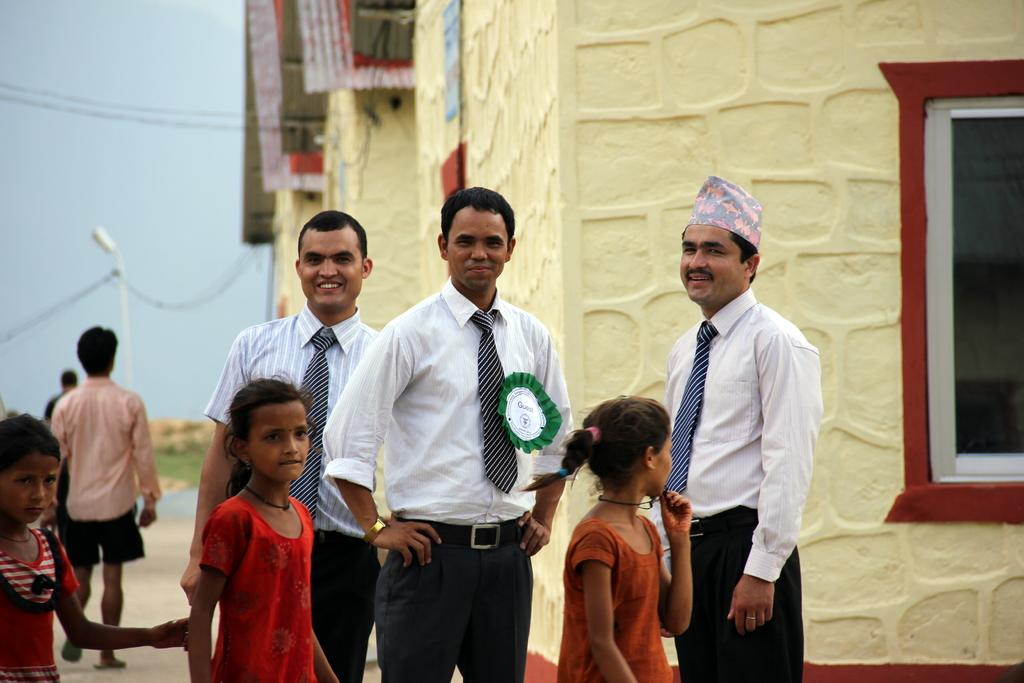What type of structures can be seen in the image? There are houses in the image. What part of a house can be seen in the image? There is a window visible in the image. What type of lighting fixture is present in the image? There is a street lamp in the image. Can you describe the people present in the image? There are people present in the image. What is visible in the background of the image? The sky is visible in the image. What type of pipe can be seen in the image? There is no pipe present in the image. What type of grape can be seen growing on the houses in the image? There are no grapes present in the image, and the houses are not depicted as having any plants or vegetation growing on them. 